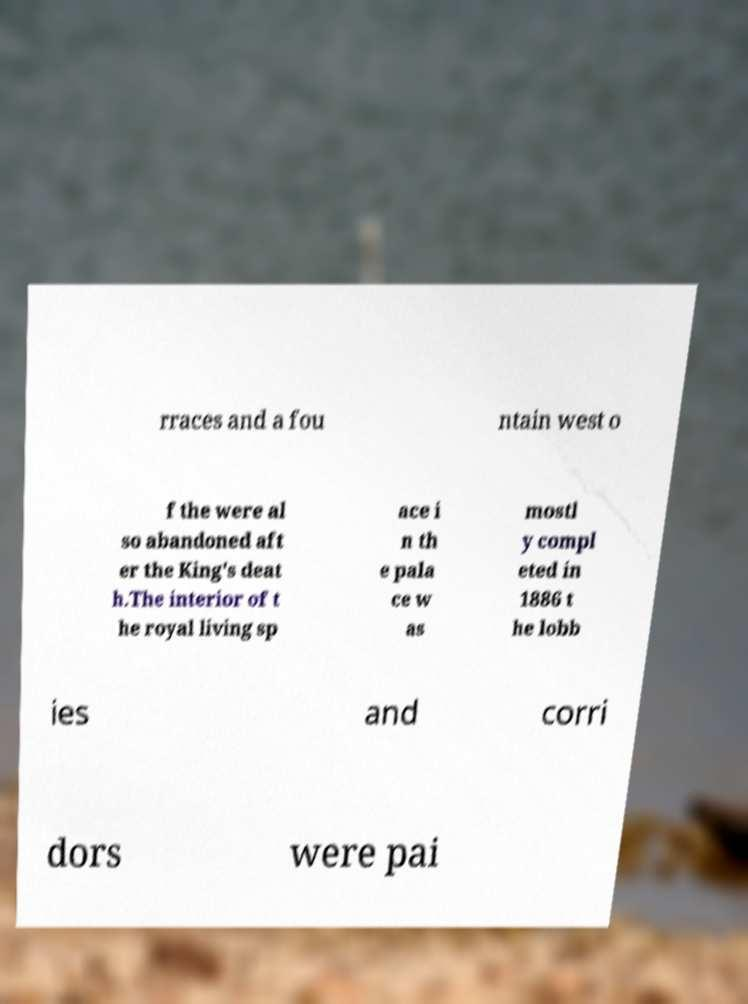What messages or text are displayed in this image? I need them in a readable, typed format. rraces and a fou ntain west o f the were al so abandoned aft er the King's deat h.The interior of t he royal living sp ace i n th e pala ce w as mostl y compl eted in 1886 t he lobb ies and corri dors were pai 